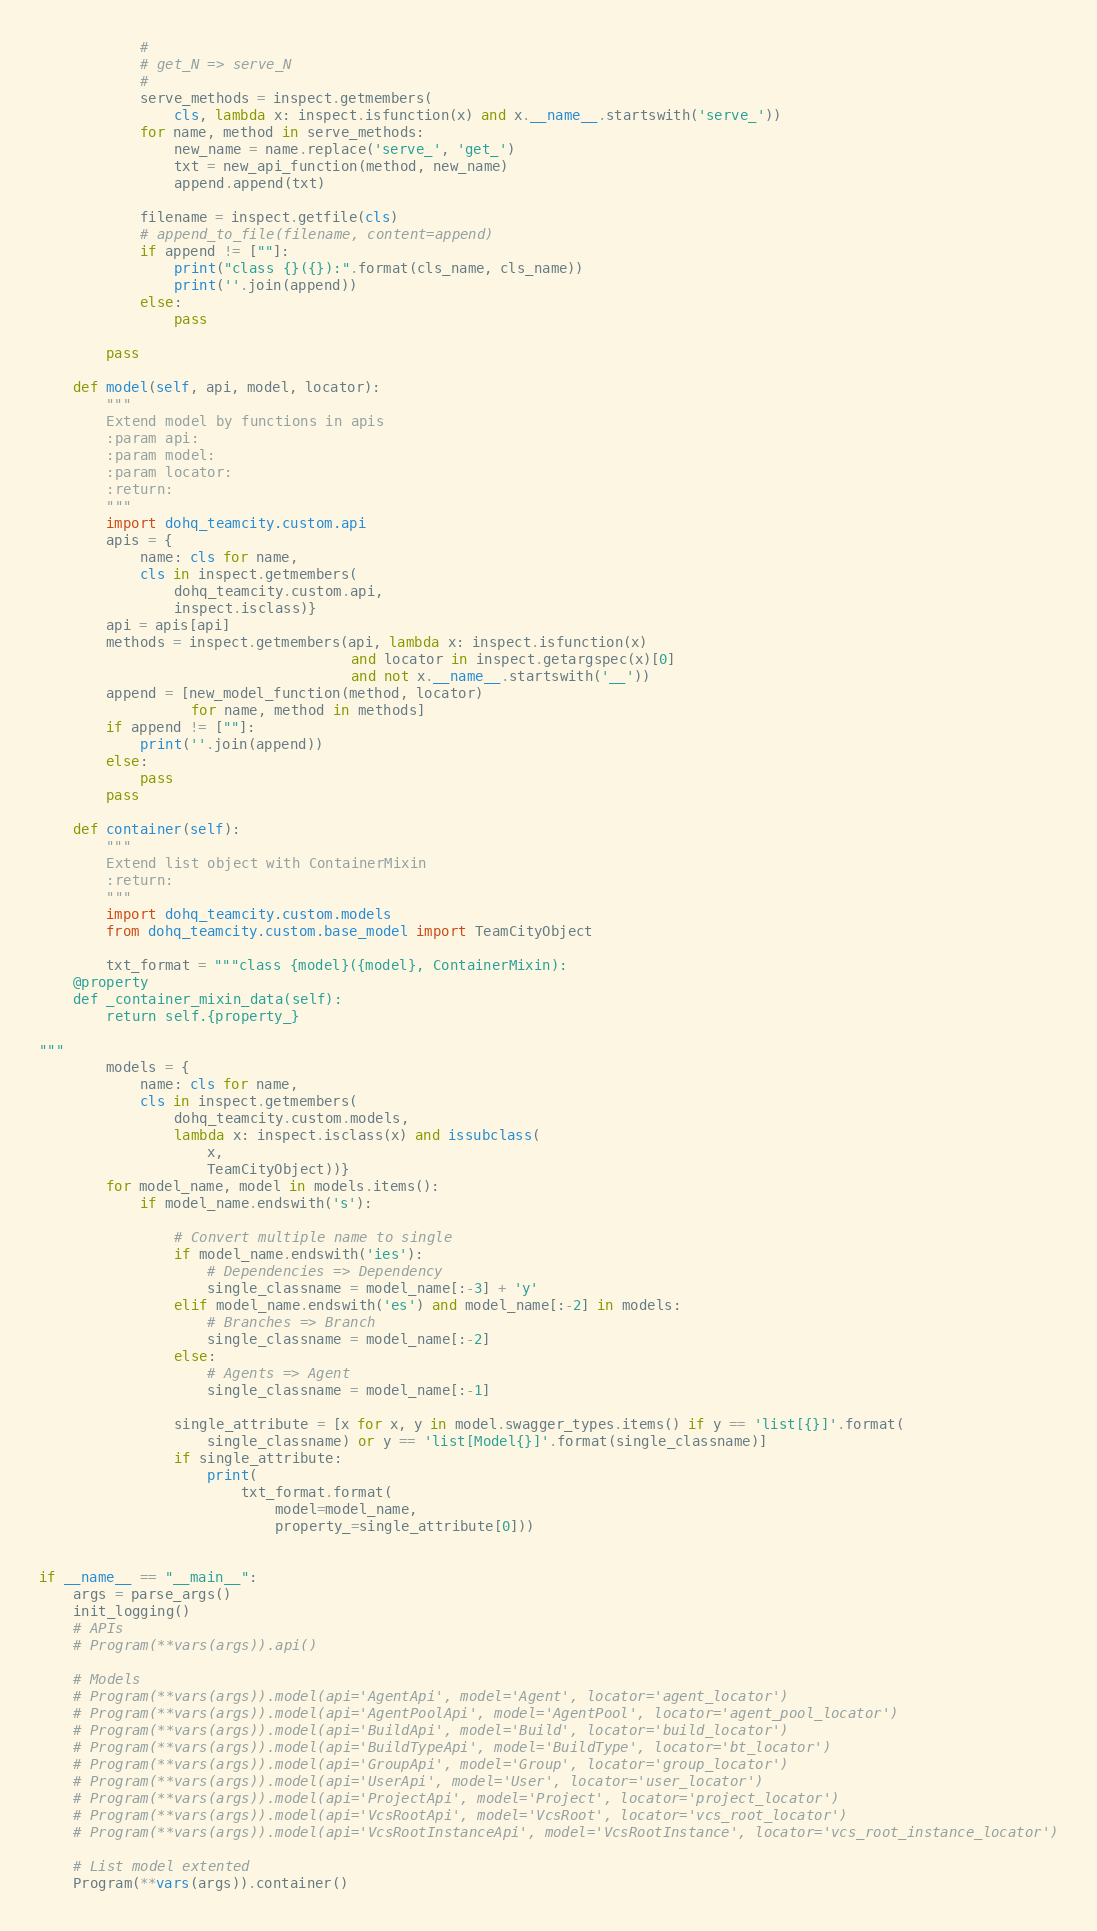Convert code to text. <code><loc_0><loc_0><loc_500><loc_500><_Python_>            #
            # get_N => serve_N
            #
            serve_methods = inspect.getmembers(
                cls, lambda x: inspect.isfunction(x) and x.__name__.startswith('serve_'))
            for name, method in serve_methods:
                new_name = name.replace('serve_', 'get_')
                txt = new_api_function(method, new_name)
                append.append(txt)

            filename = inspect.getfile(cls)
            # append_to_file(filename, content=append)
            if append != [""]:
                print("class {}({}):".format(cls_name, cls_name))
                print(''.join(append))
            else:
                pass

        pass

    def model(self, api, model, locator):
        """
        Extend model by functions in apis
        :param api:
        :param model:
        :param locator:
        :return:
        """
        import dohq_teamcity.custom.api
        apis = {
            name: cls for name,
            cls in inspect.getmembers(
                dohq_teamcity.custom.api,
                inspect.isclass)}
        api = apis[api]
        methods = inspect.getmembers(api, lambda x: inspect.isfunction(x)
                                     and locator in inspect.getargspec(x)[0]
                                     and not x.__name__.startswith('__'))
        append = [new_model_function(method, locator)
                  for name, method in methods]
        if append != [""]:
            print(''.join(append))
        else:
            pass
        pass

    def container(self):
        """
        Extend list object with ContainerMixin
        :return:
        """
        import dohq_teamcity.custom.models
        from dohq_teamcity.custom.base_model import TeamCityObject

        txt_format = """class {model}({model}, ContainerMixin):
    @property
    def _container_mixin_data(self):
        return self.{property_}

"""
        models = {
            name: cls for name,
            cls in inspect.getmembers(
                dohq_teamcity.custom.models,
                lambda x: inspect.isclass(x) and issubclass(
                    x,
                    TeamCityObject))}
        for model_name, model in models.items():
            if model_name.endswith('s'):

                # Convert multiple name to single
                if model_name.endswith('ies'):
                    # Dependencies => Dependency
                    single_classname = model_name[:-3] + 'y'
                elif model_name.endswith('es') and model_name[:-2] in models:
                    # Branches => Branch
                    single_classname = model_name[:-2]
                else:
                    # Agents => Agent
                    single_classname = model_name[:-1]

                single_attribute = [x for x, y in model.swagger_types.items() if y == 'list[{}]'.format(
                    single_classname) or y == 'list[Model{}]'.format(single_classname)]
                if single_attribute:
                    print(
                        txt_format.format(
                            model=model_name,
                            property_=single_attribute[0]))


if __name__ == "__main__":
    args = parse_args()
    init_logging()
    # APIs
    # Program(**vars(args)).api()

    # Models
    # Program(**vars(args)).model(api='AgentApi', model='Agent', locator='agent_locator')
    # Program(**vars(args)).model(api='AgentPoolApi', model='AgentPool', locator='agent_pool_locator')
    # Program(**vars(args)).model(api='BuildApi', model='Build', locator='build_locator')
    # Program(**vars(args)).model(api='BuildTypeApi', model='BuildType', locator='bt_locator')
    # Program(**vars(args)).model(api='GroupApi', model='Group', locator='group_locator')
    # Program(**vars(args)).model(api='UserApi', model='User', locator='user_locator')
    # Program(**vars(args)).model(api='ProjectApi', model='Project', locator='project_locator')
    # Program(**vars(args)).model(api='VcsRootApi', model='VcsRoot', locator='vcs_root_locator')
    # Program(**vars(args)).model(api='VcsRootInstanceApi', model='VcsRootInstance', locator='vcs_root_instance_locator')

    # List model extented
    Program(**vars(args)).container()
</code> 